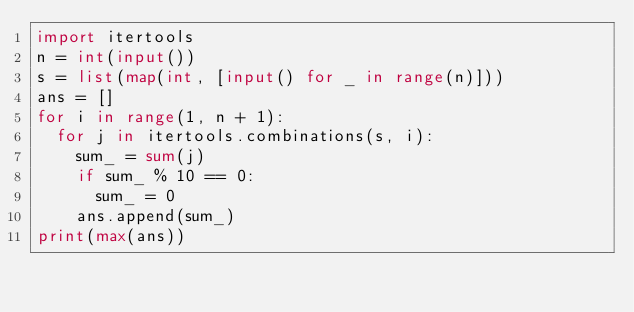<code> <loc_0><loc_0><loc_500><loc_500><_Python_>import itertools
n = int(input())
s = list(map(int, [input() for _ in range(n)]))
ans = []
for i in range(1, n + 1):
  for j in itertools.combinations(s, i):
    sum_ = sum(j)
    if sum_ % 10 == 0:
      sum_ = 0
    ans.append(sum_)
print(max(ans))</code> 